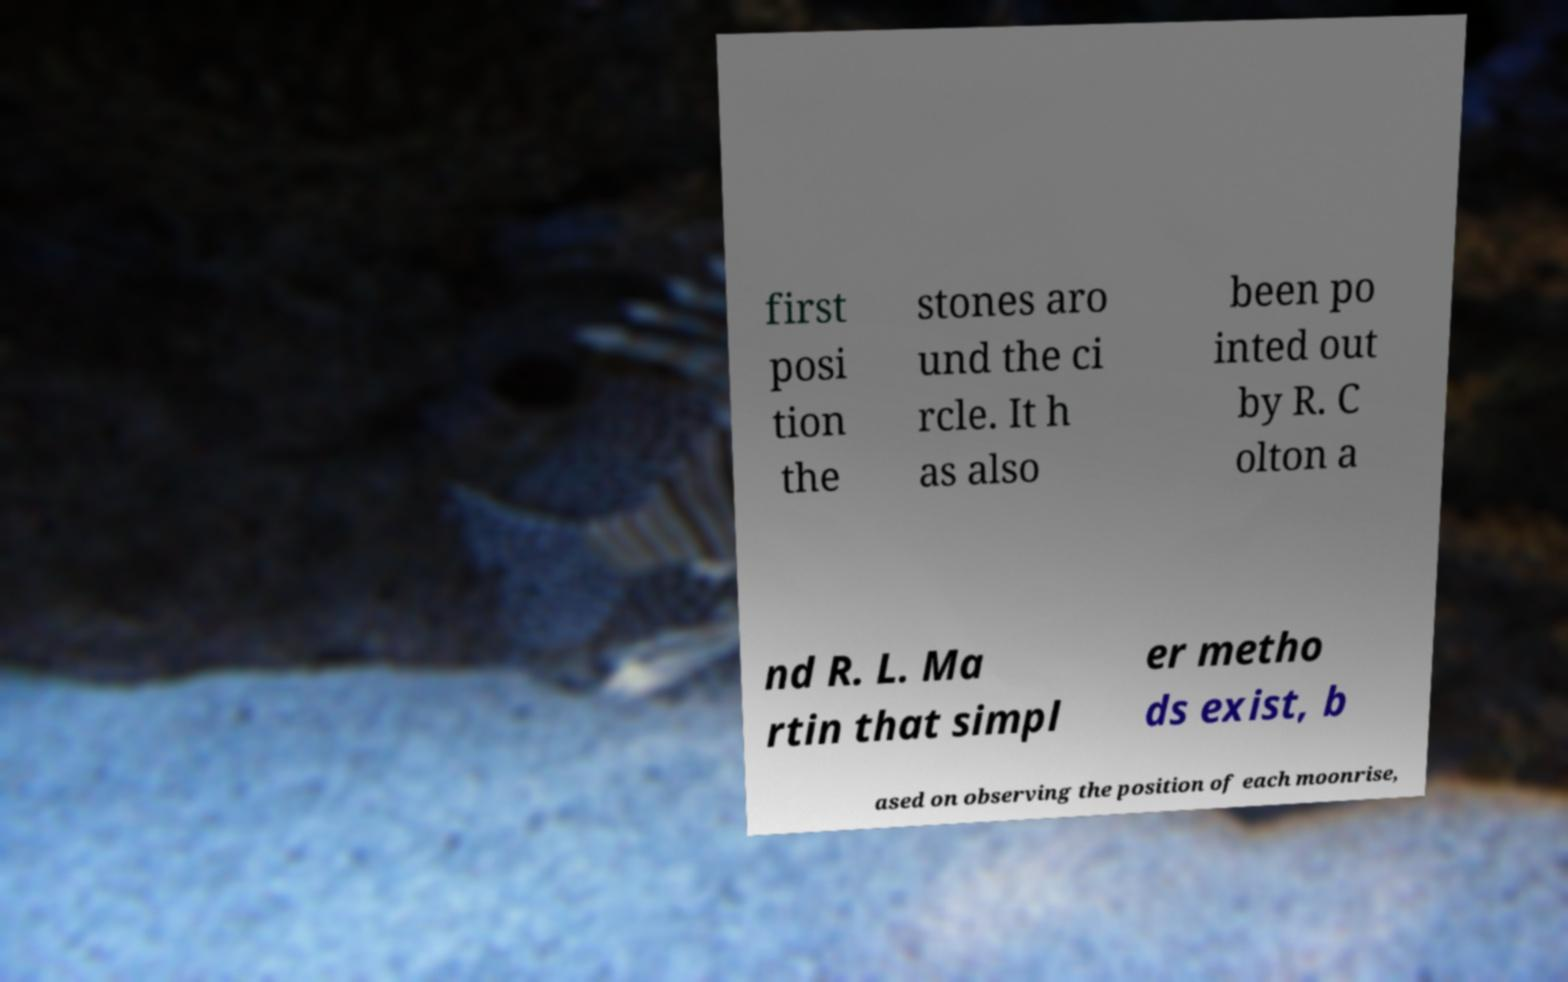For documentation purposes, I need the text within this image transcribed. Could you provide that? first posi tion the stones aro und the ci rcle. It h as also been po inted out by R. C olton a nd R. L. Ma rtin that simpl er metho ds exist, b ased on observing the position of each moonrise, 